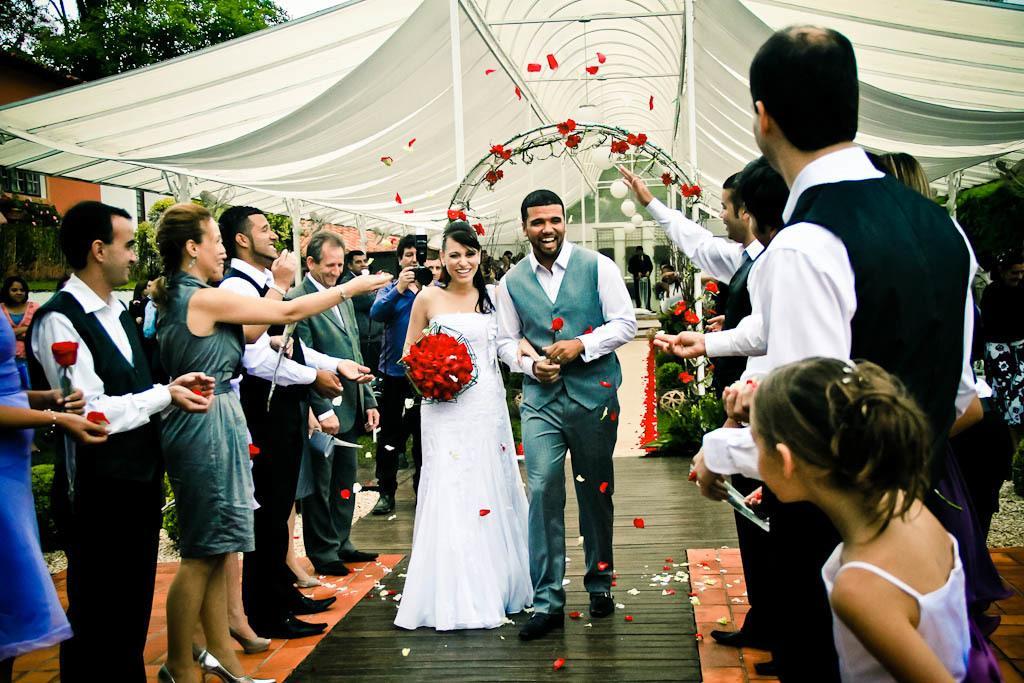How would you summarize this image in a sentence or two? In this image, we can see a couple walking, we can see some people standing, at the top there is a white color shade, at the left side top there are some green color trees. 